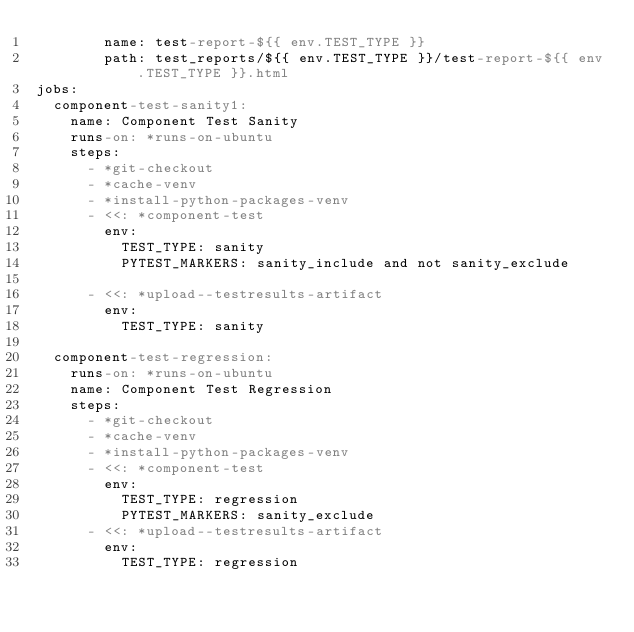Convert code to text. <code><loc_0><loc_0><loc_500><loc_500><_YAML_>        name: test-report-${{ env.TEST_TYPE }}
        path: test_reports/${{ env.TEST_TYPE }}/test-report-${{ env.TEST_TYPE }}.html
jobs:
  component-test-sanity1:
    name: Component Test Sanity
    runs-on: *runs-on-ubuntu
    steps:
      - *git-checkout
      - *cache-venv
      - *install-python-packages-venv
      - <<: *component-test
        env:
          TEST_TYPE: sanity
          PYTEST_MARKERS: sanity_include and not sanity_exclude

      - <<: *upload--testresults-artifact
        env:
          TEST_TYPE: sanity

  component-test-regression:
    runs-on: *runs-on-ubuntu
    name: Component Test Regression
    steps:
      - *git-checkout
      - *cache-venv
      - *install-python-packages-venv
      - <<: *component-test
        env:
          TEST_TYPE: regression
          PYTEST_MARKERS: sanity_exclude
      - <<: *upload--testresults-artifact
        env:
          TEST_TYPE: regression
</code> 